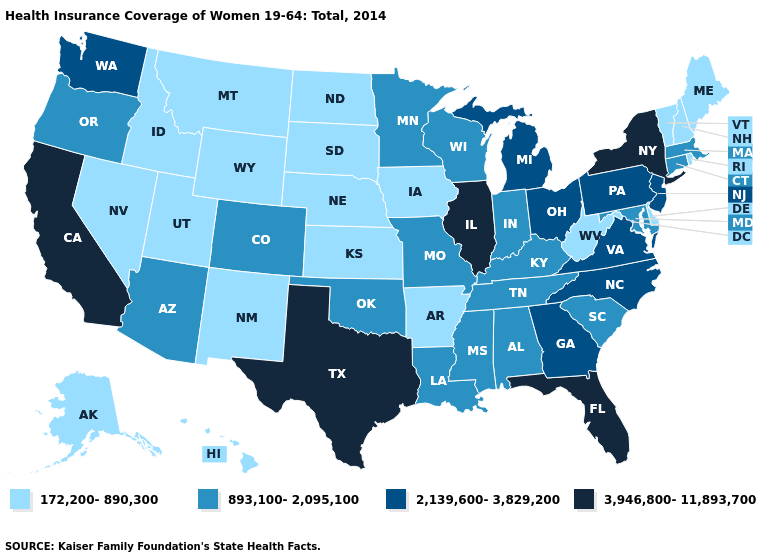Which states have the lowest value in the Northeast?
Keep it brief. Maine, New Hampshire, Rhode Island, Vermont. Is the legend a continuous bar?
Write a very short answer. No. Which states have the lowest value in the MidWest?
Give a very brief answer. Iowa, Kansas, Nebraska, North Dakota, South Dakota. What is the value of Alabama?
Quick response, please. 893,100-2,095,100. Name the states that have a value in the range 2,139,600-3,829,200?
Be succinct. Georgia, Michigan, New Jersey, North Carolina, Ohio, Pennsylvania, Virginia, Washington. What is the lowest value in states that border Iowa?
Short answer required. 172,200-890,300. Name the states that have a value in the range 2,139,600-3,829,200?
Give a very brief answer. Georgia, Michigan, New Jersey, North Carolina, Ohio, Pennsylvania, Virginia, Washington. Name the states that have a value in the range 893,100-2,095,100?
Answer briefly. Alabama, Arizona, Colorado, Connecticut, Indiana, Kentucky, Louisiana, Maryland, Massachusetts, Minnesota, Mississippi, Missouri, Oklahoma, Oregon, South Carolina, Tennessee, Wisconsin. What is the value of Washington?
Give a very brief answer. 2,139,600-3,829,200. How many symbols are there in the legend?
Give a very brief answer. 4. Name the states that have a value in the range 172,200-890,300?
Concise answer only. Alaska, Arkansas, Delaware, Hawaii, Idaho, Iowa, Kansas, Maine, Montana, Nebraska, Nevada, New Hampshire, New Mexico, North Dakota, Rhode Island, South Dakota, Utah, Vermont, West Virginia, Wyoming. Name the states that have a value in the range 893,100-2,095,100?
Quick response, please. Alabama, Arizona, Colorado, Connecticut, Indiana, Kentucky, Louisiana, Maryland, Massachusetts, Minnesota, Mississippi, Missouri, Oklahoma, Oregon, South Carolina, Tennessee, Wisconsin. What is the highest value in the USA?
Short answer required. 3,946,800-11,893,700. Name the states that have a value in the range 3,946,800-11,893,700?
Answer briefly. California, Florida, Illinois, New York, Texas. Does Minnesota have the lowest value in the USA?
Keep it brief. No. 